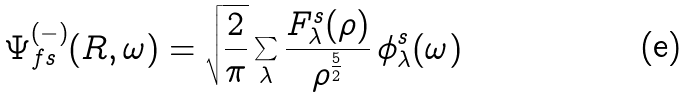<formula> <loc_0><loc_0><loc_500><loc_500>\Psi _ { f s } ^ { ( - ) } ( R , \omega ) = \sqrt { \frac { 2 } { \pi } } \sum _ { \lambda } \frac { F _ { \lambda } ^ { s } ( \rho ) } { { \rho } ^ { \frac { 5 } { 2 } } } \, \phi _ { \lambda } ^ { s } ( \omega )</formula> 